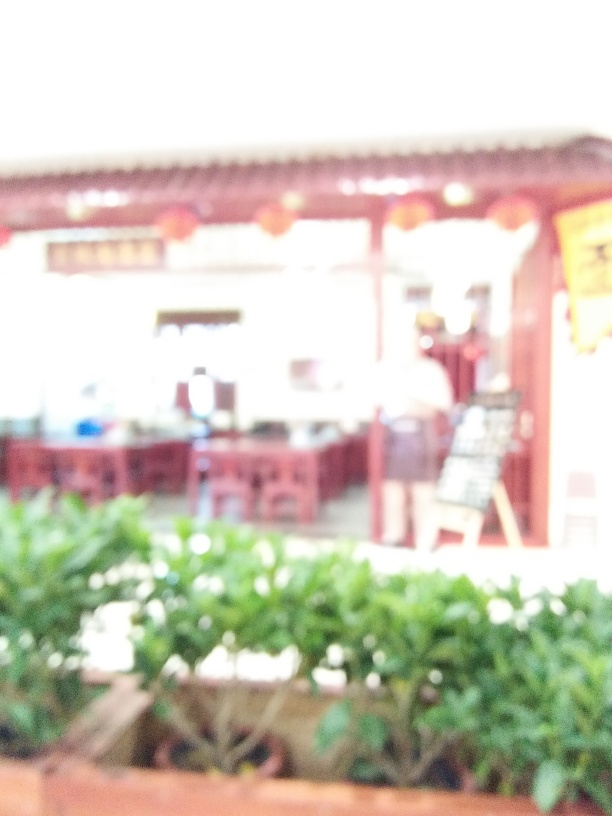Is the photo in focus? No, the photo is not in focus. The image is blurry, making it difficult to discern the fine details of the scene, such as the presence of any people, the specifics of the environment, or any text that might be present. 